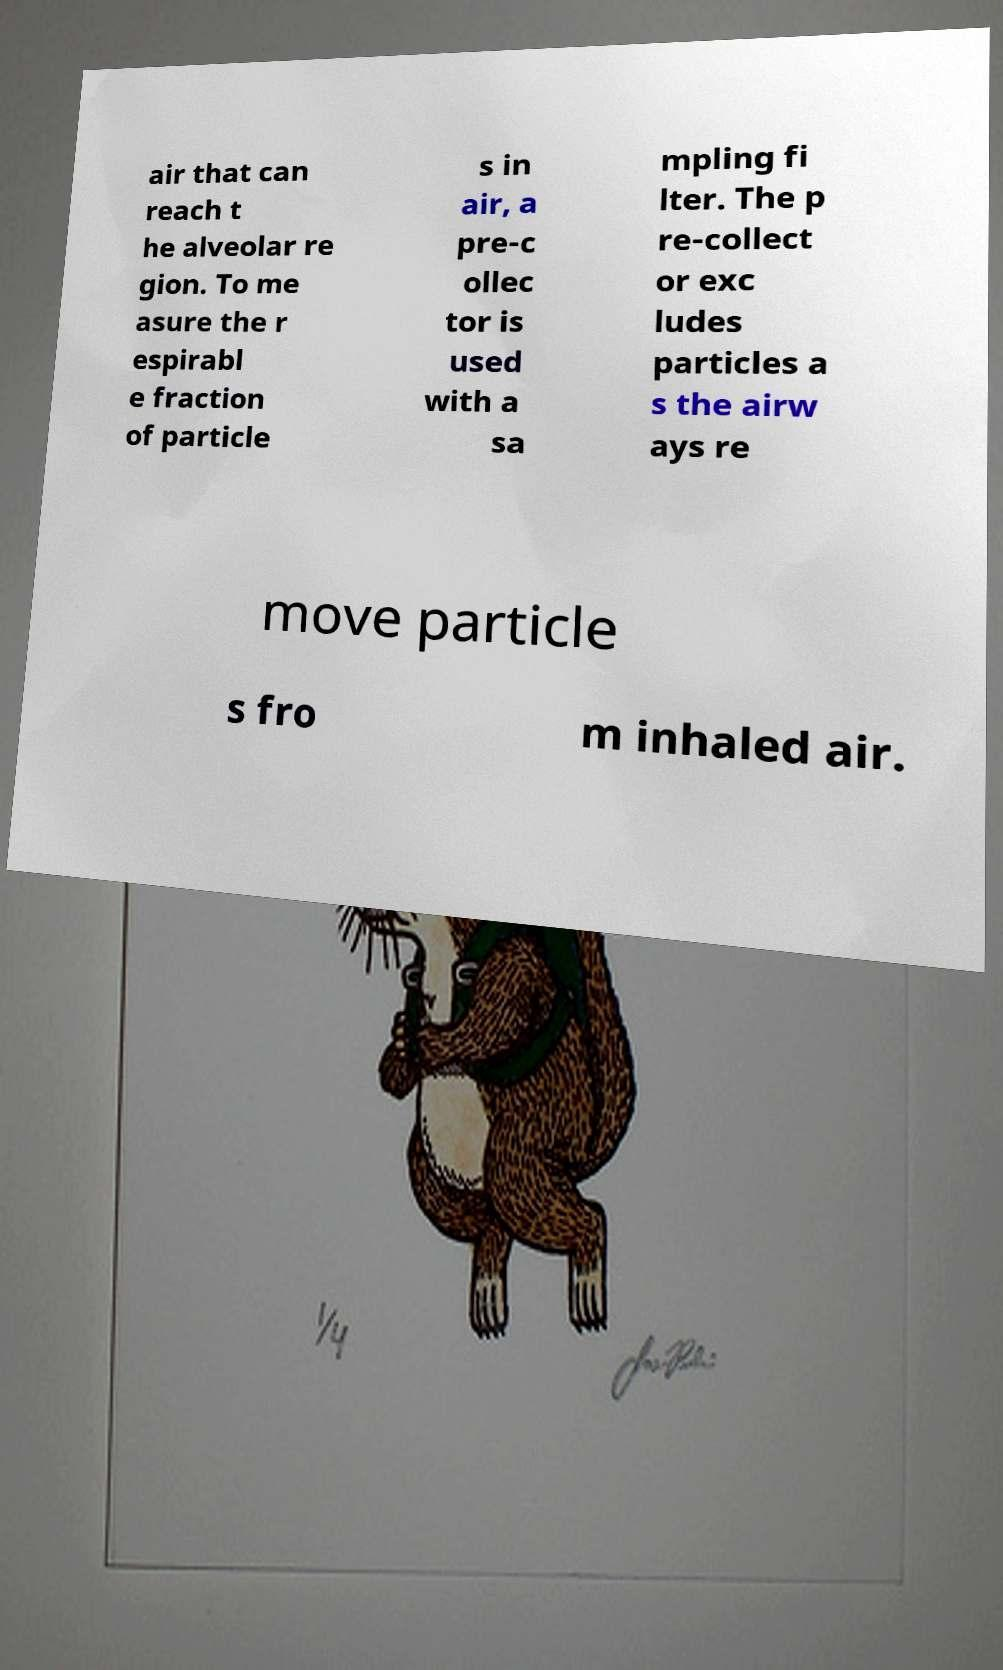There's text embedded in this image that I need extracted. Can you transcribe it verbatim? air that can reach t he alveolar re gion. To me asure the r espirabl e fraction of particle s in air, a pre-c ollec tor is used with a sa mpling fi lter. The p re-collect or exc ludes particles a s the airw ays re move particle s fro m inhaled air. 